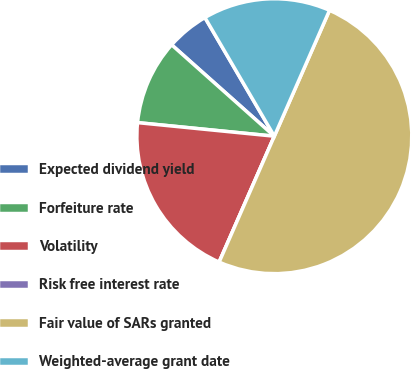<chart> <loc_0><loc_0><loc_500><loc_500><pie_chart><fcel>Expected dividend yield<fcel>Forfeiture rate<fcel>Volatility<fcel>Risk free interest rate<fcel>Fair value of SARs granted<fcel>Weighted-average grant date<nl><fcel>5.0%<fcel>10.0%<fcel>20.0%<fcel>0.0%<fcel>50.0%<fcel>15.0%<nl></chart> 